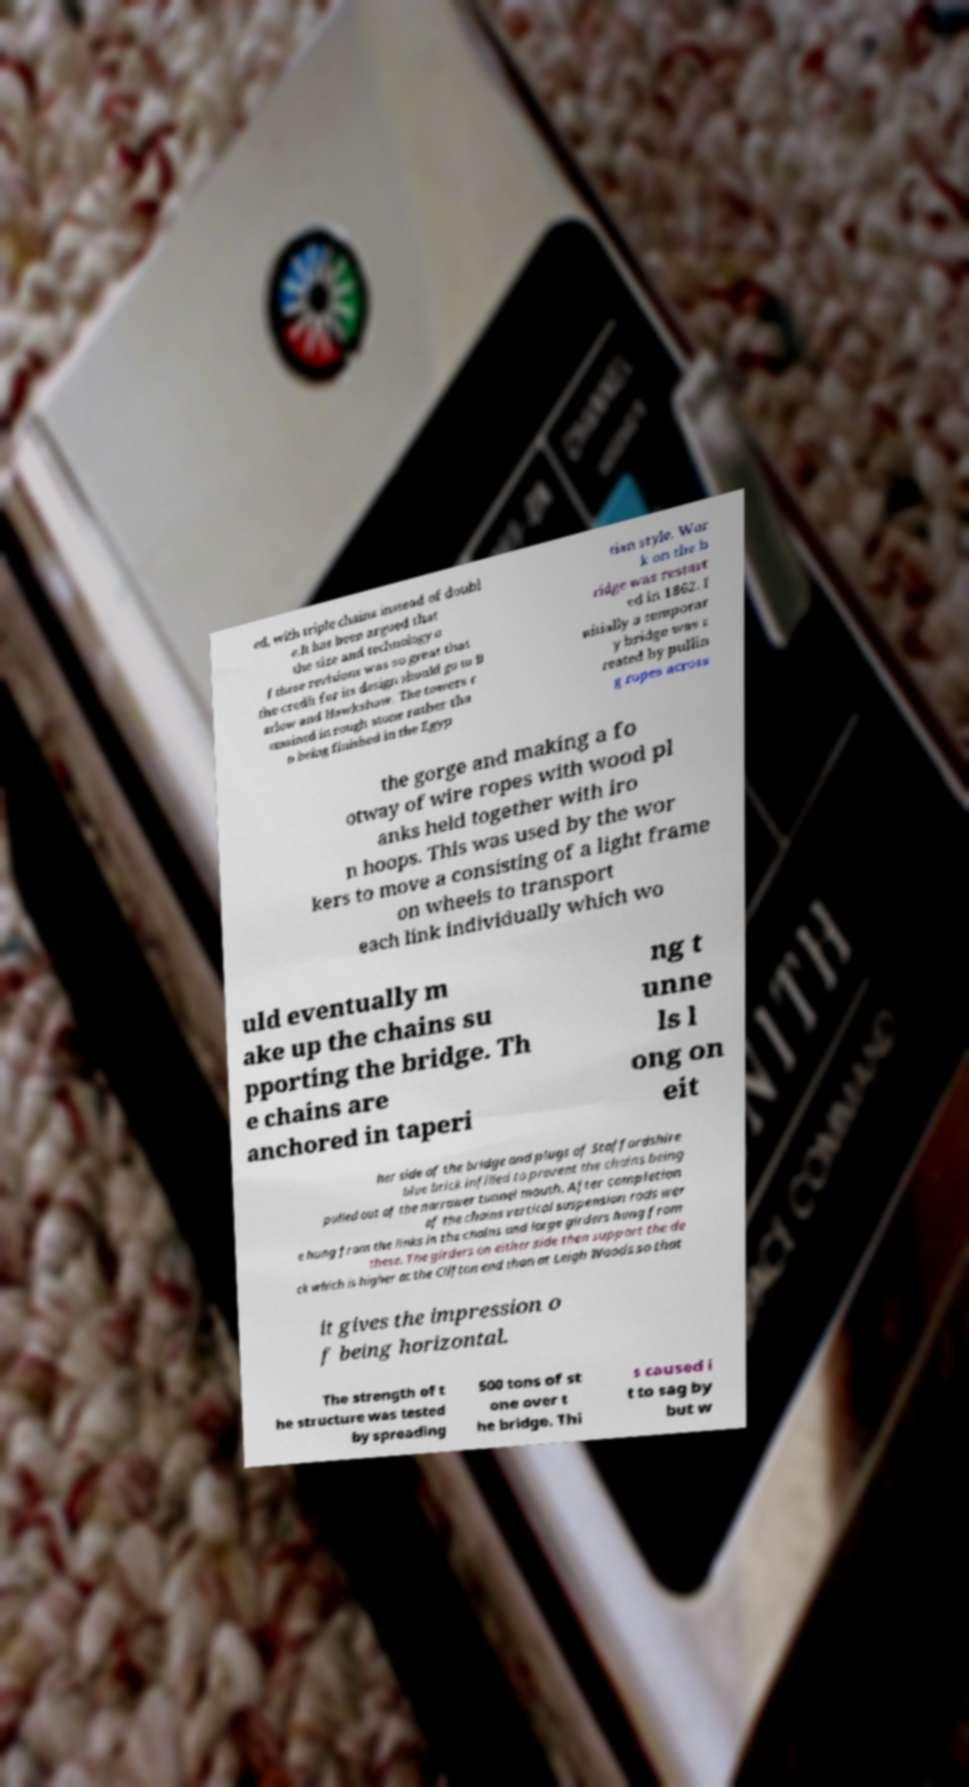What messages or text are displayed in this image? I need them in a readable, typed format. ed, with triple chains instead of doubl e.It has been argued that the size and technology o f these revisions was so great that the credit for its design should go to B arlow and Hawkshaw. The towers r emained in rough stone rather tha n being finished in the Egyp tian style. Wor k on the b ridge was restart ed in 1862. I nitially a temporar y bridge was c reated by pullin g ropes across the gorge and making a fo otway of wire ropes with wood pl anks held together with iro n hoops. This was used by the wor kers to move a consisting of a light frame on wheels to transport each link individually which wo uld eventually m ake up the chains su pporting the bridge. Th e chains are anchored in taperi ng t unne ls l ong on eit her side of the bridge and plugs of Staffordshire blue brick infilled to prevent the chains being pulled out of the narrower tunnel mouth. After completion of the chains vertical suspension rods wer e hung from the links in the chains and large girders hung from these. The girders on either side then support the de ck which is higher at the Clifton end than at Leigh Woods so that it gives the impression o f being horizontal. The strength of t he structure was tested by spreading 500 tons of st one over t he bridge. Thi s caused i t to sag by but w 